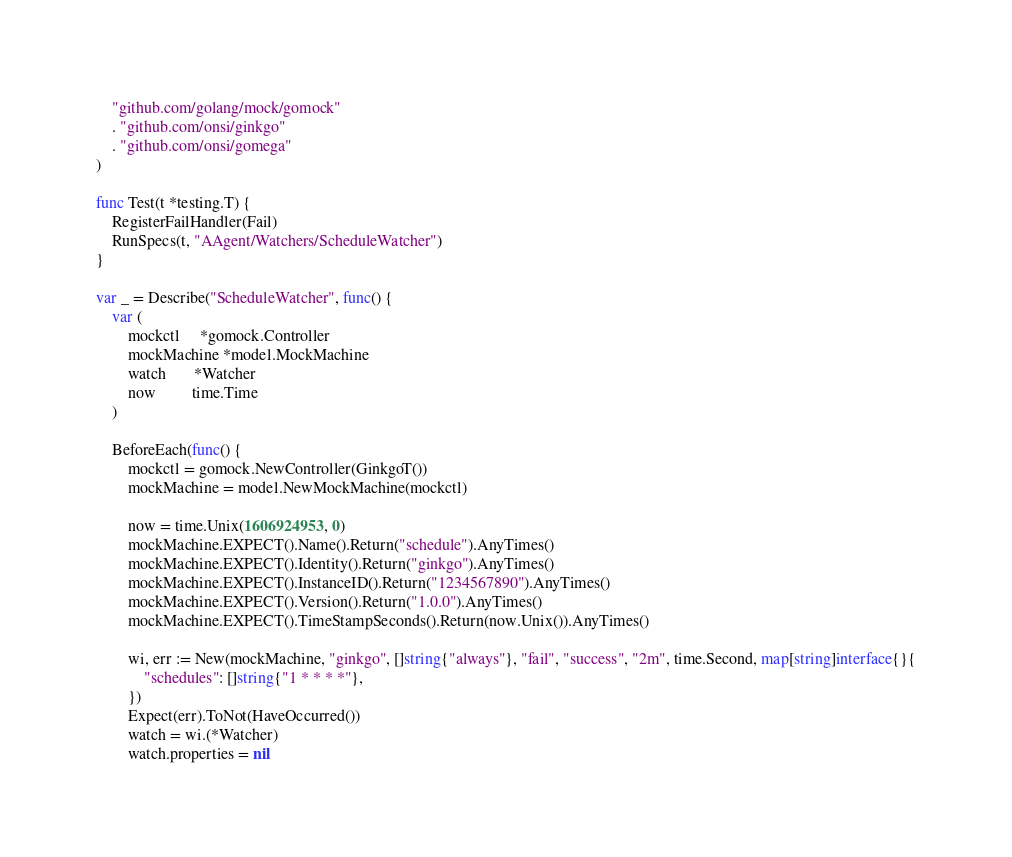Convert code to text. <code><loc_0><loc_0><loc_500><loc_500><_Go_>	"github.com/golang/mock/gomock"
	. "github.com/onsi/ginkgo"
	. "github.com/onsi/gomega"
)

func Test(t *testing.T) {
	RegisterFailHandler(Fail)
	RunSpecs(t, "AAgent/Watchers/ScheduleWatcher")
}

var _ = Describe("ScheduleWatcher", func() {
	var (
		mockctl     *gomock.Controller
		mockMachine *model.MockMachine
		watch       *Watcher
		now         time.Time
	)

	BeforeEach(func() {
		mockctl = gomock.NewController(GinkgoT())
		mockMachine = model.NewMockMachine(mockctl)

		now = time.Unix(1606924953, 0)
		mockMachine.EXPECT().Name().Return("schedule").AnyTimes()
		mockMachine.EXPECT().Identity().Return("ginkgo").AnyTimes()
		mockMachine.EXPECT().InstanceID().Return("1234567890").AnyTimes()
		mockMachine.EXPECT().Version().Return("1.0.0").AnyTimes()
		mockMachine.EXPECT().TimeStampSeconds().Return(now.Unix()).AnyTimes()

		wi, err := New(mockMachine, "ginkgo", []string{"always"}, "fail", "success", "2m", time.Second, map[string]interface{}{
			"schedules": []string{"1 * * * *"},
		})
		Expect(err).ToNot(HaveOccurred())
		watch = wi.(*Watcher)
		watch.properties = nil</code> 